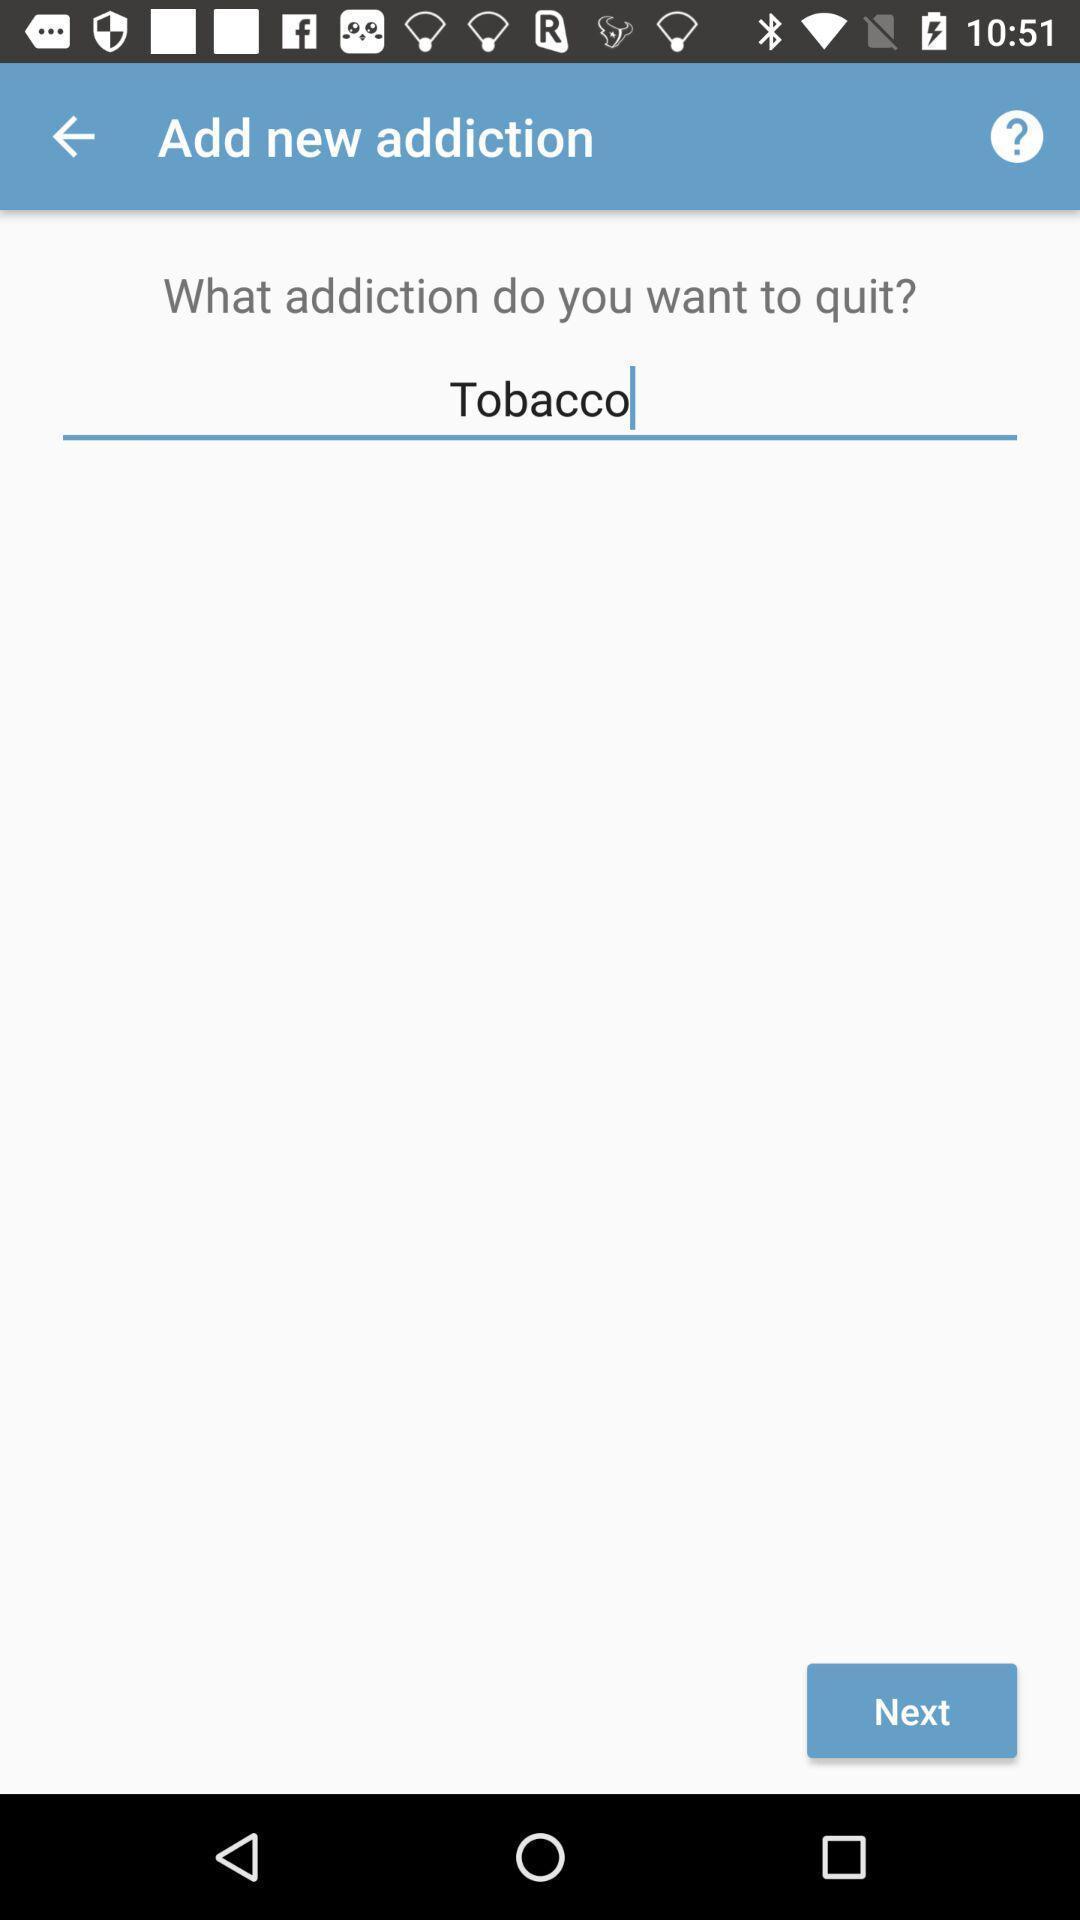Provide a detailed account of this screenshot. Screen displaying the field to enter the data. 